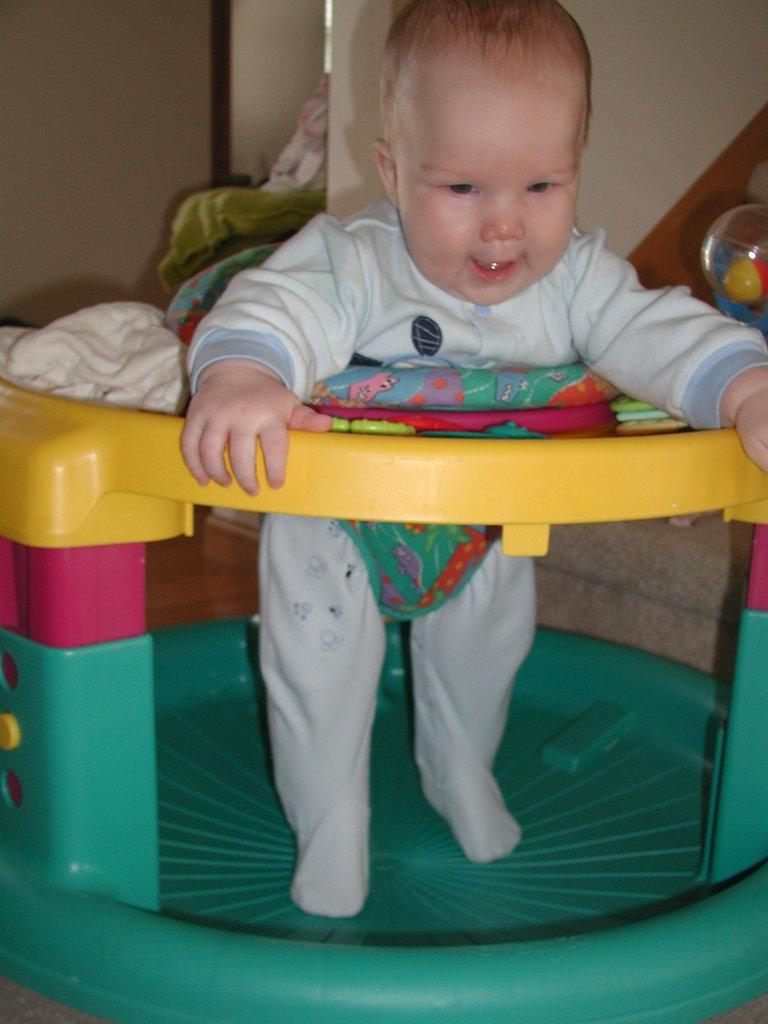What is the main subject of the image? The main subject of the image is an infant. What is the infant doing in the image? The infant is standing on a walker. What type of fruit is the infant holding in the image? There is no fruit present in the image; the infant is standing on a walker. What flavor is the walker in the image? The walker is not associated with a flavor, as it is a piece of equipment for the infant to stand on. 